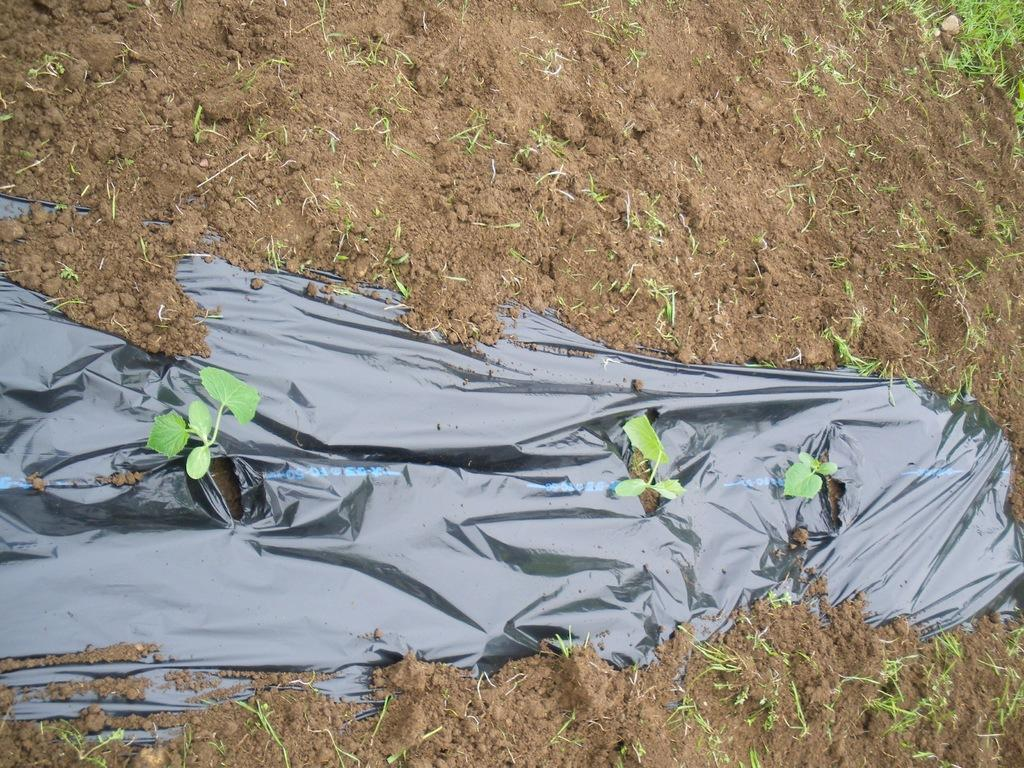What is covering the ground in the image? There are plants on the ground in the image. What else can be seen in the image besides the plants? There is a sheet in the image. What type of punishment is being administered to the lizards in the image? There are no lizards present in the image, so no punishment is being administered. What activity are the children participating in during recess in the image? There is no indication of children or a recess in the image. 